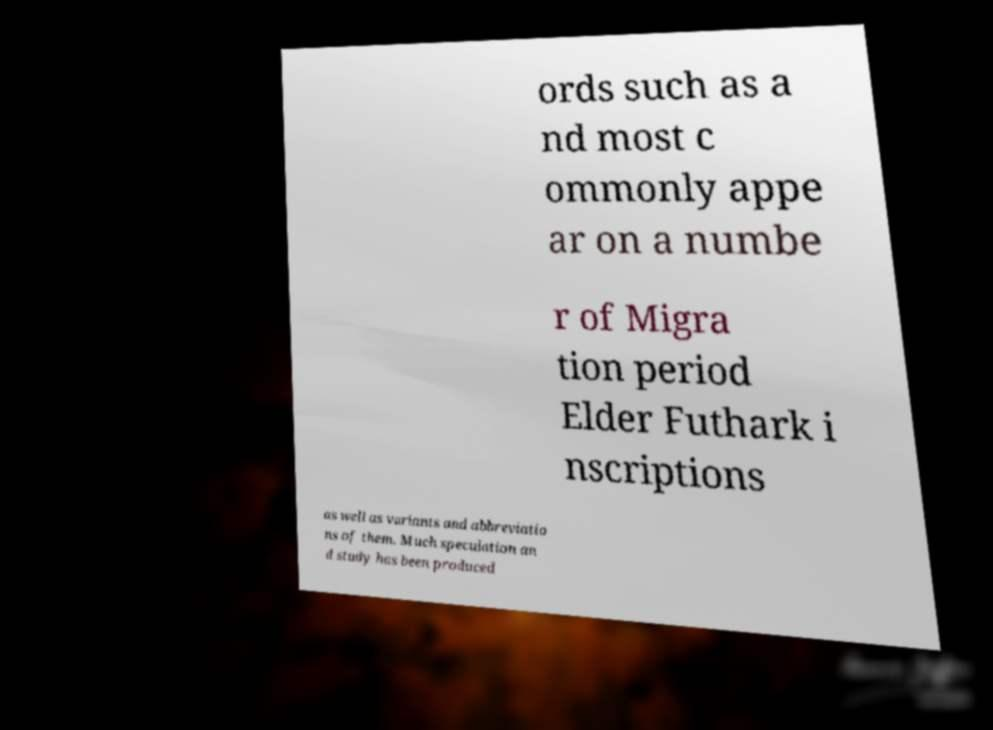Could you assist in decoding the text presented in this image and type it out clearly? ords such as a nd most c ommonly appe ar on a numbe r of Migra tion period Elder Futhark i nscriptions as well as variants and abbreviatio ns of them. Much speculation an d study has been produced 